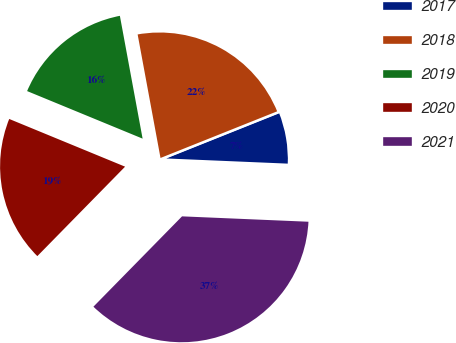Convert chart. <chart><loc_0><loc_0><loc_500><loc_500><pie_chart><fcel>2017<fcel>2018<fcel>2019<fcel>2020<fcel>2021<nl><fcel>6.73%<fcel>21.86%<fcel>15.87%<fcel>18.87%<fcel>36.67%<nl></chart> 